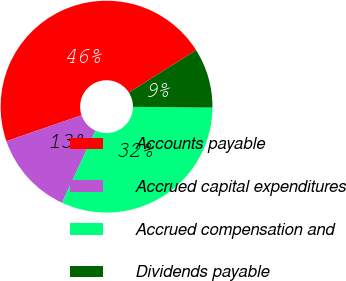<chart> <loc_0><loc_0><loc_500><loc_500><pie_chart><fcel>Accounts payable<fcel>Accrued capital expenditures<fcel>Accrued compensation and<fcel>Dividends payable<nl><fcel>46.33%<fcel>12.82%<fcel>31.75%<fcel>9.1%<nl></chart> 